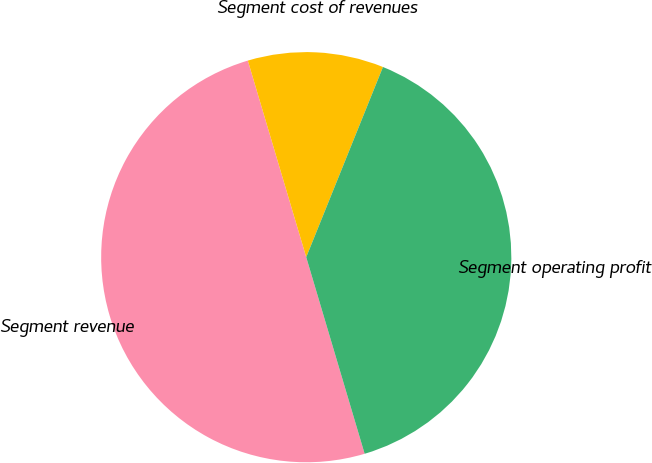<chart> <loc_0><loc_0><loc_500><loc_500><pie_chart><fcel>Segment revenue<fcel>Segment cost of revenues<fcel>Segment operating profit<nl><fcel>50.0%<fcel>10.7%<fcel>39.3%<nl></chart> 